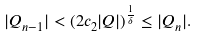<formula> <loc_0><loc_0><loc_500><loc_500>| Q _ { n - 1 } | < ( 2 c _ { 2 } | Q | ) ^ { \frac { 1 } { \delta } } \leq | Q _ { n } | .</formula> 